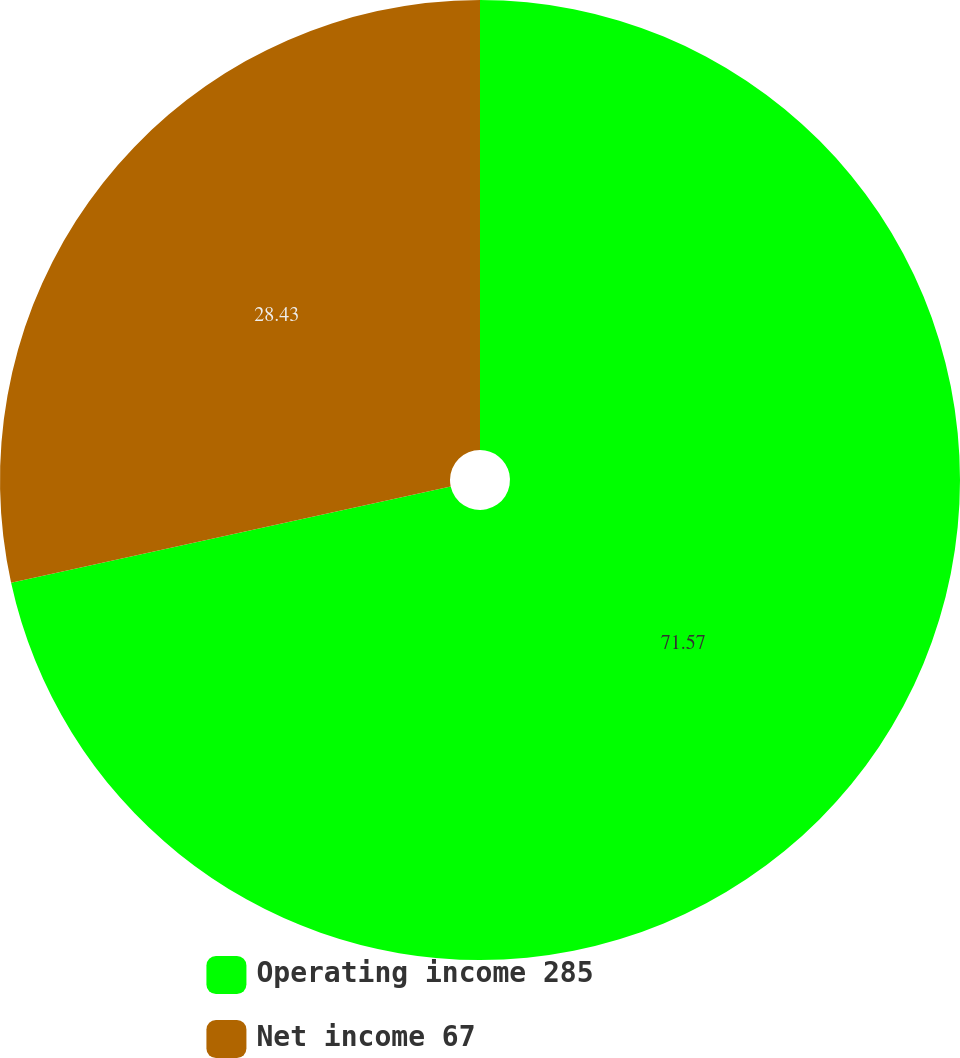<chart> <loc_0><loc_0><loc_500><loc_500><pie_chart><fcel>Operating income 285<fcel>Net income 67<nl><fcel>71.57%<fcel>28.43%<nl></chart> 